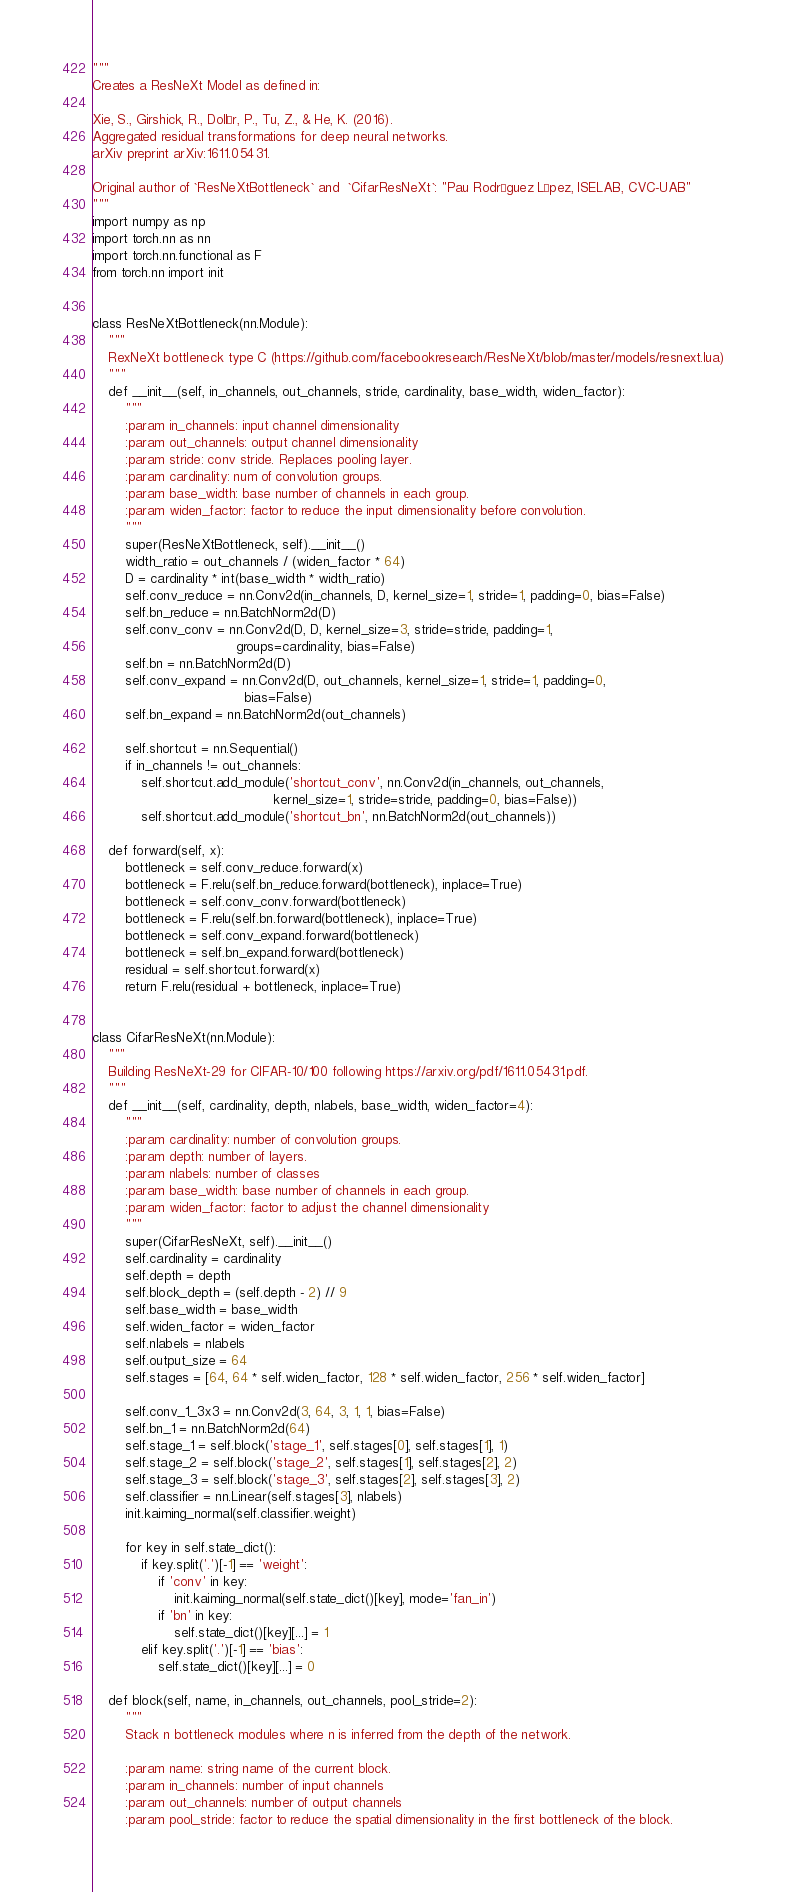Convert code to text. <code><loc_0><loc_0><loc_500><loc_500><_Python_>"""
Creates a ResNeXt Model as defined in:

Xie, S., Girshick, R., Dollár, P., Tu, Z., & He, K. (2016).
Aggregated residual transformations for deep neural networks.
arXiv preprint arXiv:1611.05431.

Original author of `ResNeXtBottleneck` and  `CifarResNeXt`: "Pau Rodríguez López, ISELAB, CVC-UAB"
"""
import numpy as np
import torch.nn as nn
import torch.nn.functional as F
from torch.nn import init


class ResNeXtBottleneck(nn.Module):
    """
    RexNeXt bottleneck type C (https://github.com/facebookresearch/ResNeXt/blob/master/models/resnext.lua)
    """
    def __init__(self, in_channels, out_channels, stride, cardinality, base_width, widen_factor):
        """
        :param in_channels: input channel dimensionality
        :param out_channels: output channel dimensionality
        :param stride: conv stride. Replaces pooling layer.
        :param cardinality: num of convolution groups.
        :param base_width: base number of channels in each group.
        :param widen_factor: factor to reduce the input dimensionality before convolution.
        """
        super(ResNeXtBottleneck, self).__init__()
        width_ratio = out_channels / (widen_factor * 64)
        D = cardinality * int(base_width * width_ratio)
        self.conv_reduce = nn.Conv2d(in_channels, D, kernel_size=1, stride=1, padding=0, bias=False)
        self.bn_reduce = nn.BatchNorm2d(D)
        self.conv_conv = nn.Conv2d(D, D, kernel_size=3, stride=stride, padding=1,
                                   groups=cardinality, bias=False)
        self.bn = nn.BatchNorm2d(D)
        self.conv_expand = nn.Conv2d(D, out_channels, kernel_size=1, stride=1, padding=0,
                                     bias=False)
        self.bn_expand = nn.BatchNorm2d(out_channels)

        self.shortcut = nn.Sequential()
        if in_channels != out_channels:
            self.shortcut.add_module('shortcut_conv', nn.Conv2d(in_channels, out_channels,
                                            kernel_size=1, stride=stride, padding=0, bias=False))
            self.shortcut.add_module('shortcut_bn', nn.BatchNorm2d(out_channels))

    def forward(self, x):
        bottleneck = self.conv_reduce.forward(x)
        bottleneck = F.relu(self.bn_reduce.forward(bottleneck), inplace=True)
        bottleneck = self.conv_conv.forward(bottleneck)
        bottleneck = F.relu(self.bn.forward(bottleneck), inplace=True)
        bottleneck = self.conv_expand.forward(bottleneck)
        bottleneck = self.bn_expand.forward(bottleneck)
        residual = self.shortcut.forward(x)
        return F.relu(residual + bottleneck, inplace=True)


class CifarResNeXt(nn.Module):
    """
    Building ResNeXt-29 for CIFAR-10/100 following https://arxiv.org/pdf/1611.05431.pdf.
    """
    def __init__(self, cardinality, depth, nlabels, base_width, widen_factor=4):
        """
        :param cardinality: number of convolution groups.
        :param depth: number of layers.
        :param nlabels: number of classes
        :param base_width: base number of channels in each group.
        :param widen_factor: factor to adjust the channel dimensionality
        """
        super(CifarResNeXt, self).__init__()
        self.cardinality = cardinality
        self.depth = depth
        self.block_depth = (self.depth - 2) // 9
        self.base_width = base_width
        self.widen_factor = widen_factor
        self.nlabels = nlabels
        self.output_size = 64
        self.stages = [64, 64 * self.widen_factor, 128 * self.widen_factor, 256 * self.widen_factor]

        self.conv_1_3x3 = nn.Conv2d(3, 64, 3, 1, 1, bias=False)
        self.bn_1 = nn.BatchNorm2d(64)
        self.stage_1 = self.block('stage_1', self.stages[0], self.stages[1], 1)
        self.stage_2 = self.block('stage_2', self.stages[1], self.stages[2], 2)
        self.stage_3 = self.block('stage_3', self.stages[2], self.stages[3], 2)
        self.classifier = nn.Linear(self.stages[3], nlabels)
        init.kaiming_normal(self.classifier.weight)

        for key in self.state_dict():
            if key.split('.')[-1] == 'weight':
                if 'conv' in key:
                    init.kaiming_normal(self.state_dict()[key], mode='fan_in')
                if 'bn' in key:
                    self.state_dict()[key][...] = 1
            elif key.split('.')[-1] == 'bias':
                self.state_dict()[key][...] = 0

    def block(self, name, in_channels, out_channels, pool_stride=2):
        """
        Stack n bottleneck modules where n is inferred from the depth of the network.

        :param name: string name of the current block.
        :param in_channels: number of input channels
        :param out_channels: number of output channels
        :param pool_stride: factor to reduce the spatial dimensionality in the first bottleneck of the block.</code> 